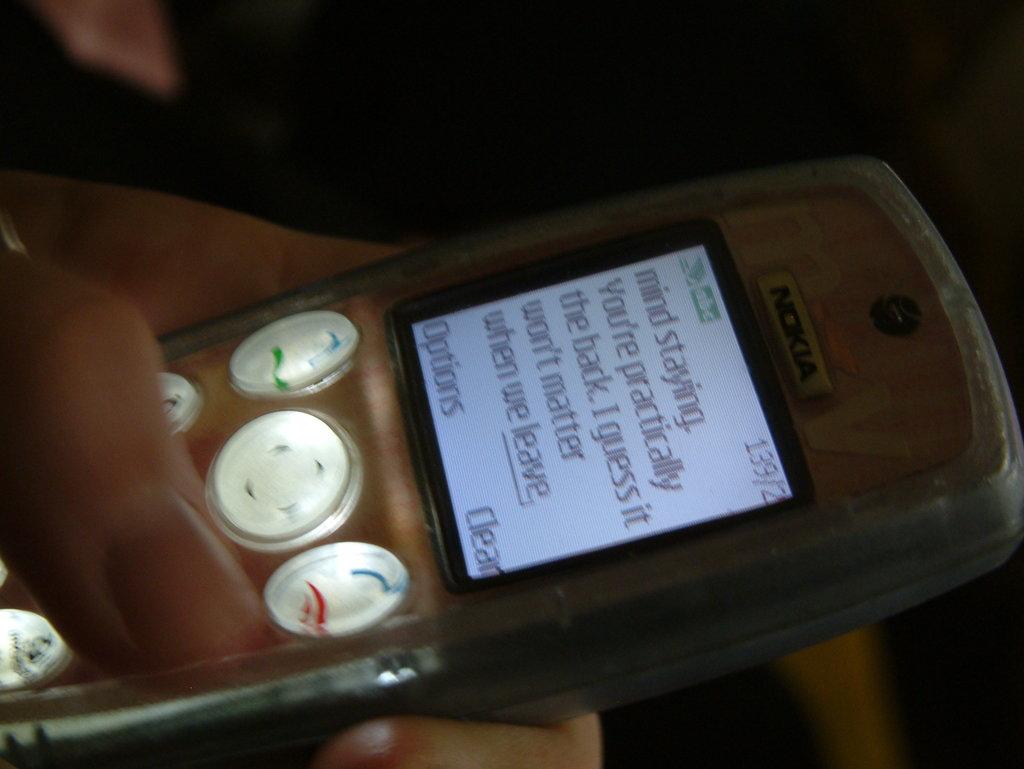What is the person reading?
Provide a succinct answer. Text message. What is the option on the bottom left of the phone screen?
Give a very brief answer. Options. 